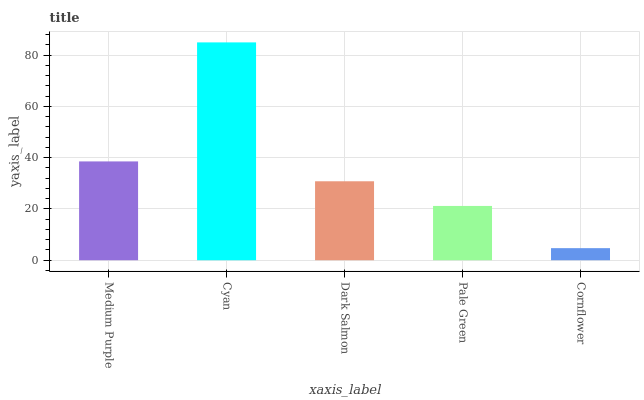Is Cornflower the minimum?
Answer yes or no. Yes. Is Cyan the maximum?
Answer yes or no. Yes. Is Dark Salmon the minimum?
Answer yes or no. No. Is Dark Salmon the maximum?
Answer yes or no. No. Is Cyan greater than Dark Salmon?
Answer yes or no. Yes. Is Dark Salmon less than Cyan?
Answer yes or no. Yes. Is Dark Salmon greater than Cyan?
Answer yes or no. No. Is Cyan less than Dark Salmon?
Answer yes or no. No. Is Dark Salmon the high median?
Answer yes or no. Yes. Is Dark Salmon the low median?
Answer yes or no. Yes. Is Cornflower the high median?
Answer yes or no. No. Is Pale Green the low median?
Answer yes or no. No. 